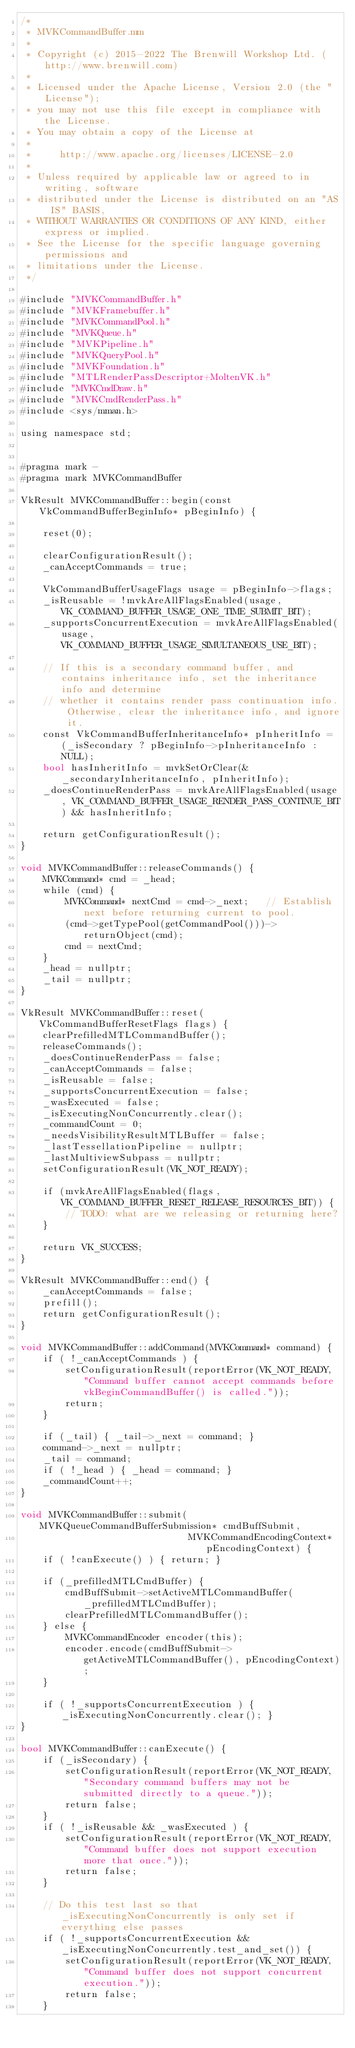<code> <loc_0><loc_0><loc_500><loc_500><_ObjectiveC_>/*
 * MVKCommandBuffer.mm
 *
 * Copyright (c) 2015-2022 The Brenwill Workshop Ltd. (http://www.brenwill.com)
 *
 * Licensed under the Apache License, Version 2.0 (the "License");
 * you may not use this file except in compliance with the License.
 * You may obtain a copy of the License at
 * 
 *     http://www.apache.org/licenses/LICENSE-2.0
 * 
 * Unless required by applicable law or agreed to in writing, software
 * distributed under the License is distributed on an "AS IS" BASIS,
 * WITHOUT WARRANTIES OR CONDITIONS OF ANY KIND, either express or implied.
 * See the License for the specific language governing permissions and
 * limitations under the License.
 */

#include "MVKCommandBuffer.h"
#include "MVKFramebuffer.h"
#include "MVKCommandPool.h"
#include "MVKQueue.h"
#include "MVKPipeline.h"
#include "MVKQueryPool.h"
#include "MVKFoundation.h"
#include "MTLRenderPassDescriptor+MoltenVK.h"
#include "MVKCmdDraw.h"
#include "MVKCmdRenderPass.h"
#include <sys/mman.h>

using namespace std;


#pragma mark -
#pragma mark MVKCommandBuffer

VkResult MVKCommandBuffer::begin(const VkCommandBufferBeginInfo* pBeginInfo) {

	reset(0);

	clearConfigurationResult();
	_canAcceptCommands = true;

	VkCommandBufferUsageFlags usage = pBeginInfo->flags;
	_isReusable = !mvkAreAllFlagsEnabled(usage, VK_COMMAND_BUFFER_USAGE_ONE_TIME_SUBMIT_BIT);
	_supportsConcurrentExecution = mvkAreAllFlagsEnabled(usage, VK_COMMAND_BUFFER_USAGE_SIMULTANEOUS_USE_BIT);

	// If this is a secondary command buffer, and contains inheritance info, set the inheritance info and determine
	// whether it contains render pass continuation info. Otherwise, clear the inheritance info, and ignore it.
	const VkCommandBufferInheritanceInfo* pInheritInfo = (_isSecondary ? pBeginInfo->pInheritanceInfo : NULL);
	bool hasInheritInfo = mvkSetOrClear(&_secondaryInheritanceInfo, pInheritInfo);
	_doesContinueRenderPass = mvkAreAllFlagsEnabled(usage, VK_COMMAND_BUFFER_USAGE_RENDER_PASS_CONTINUE_BIT) && hasInheritInfo;

	return getConfigurationResult();
}

void MVKCommandBuffer::releaseCommands() {
	MVKCommand* cmd = _head;
	while (cmd) {
		MVKCommand* nextCmd = cmd->_next;	// Establish next before returning current to pool.
		(cmd->getTypePool(getCommandPool()))->returnObject(cmd);
		cmd = nextCmd;
	}
	_head = nullptr;
	_tail = nullptr;
}

VkResult MVKCommandBuffer::reset(VkCommandBufferResetFlags flags) {
	clearPrefilledMTLCommandBuffer();
	releaseCommands();
	_doesContinueRenderPass = false;
	_canAcceptCommands = false;
	_isReusable = false;
	_supportsConcurrentExecution = false;
	_wasExecuted = false;
	_isExecutingNonConcurrently.clear();
	_commandCount = 0;
	_needsVisibilityResultMTLBuffer = false;
	_lastTessellationPipeline = nullptr;
	_lastMultiviewSubpass = nullptr;
	setConfigurationResult(VK_NOT_READY);

	if (mvkAreAllFlagsEnabled(flags, VK_COMMAND_BUFFER_RESET_RELEASE_RESOURCES_BIT)) {
		// TODO: what are we releasing or returning here?
	}

	return VK_SUCCESS;
}

VkResult MVKCommandBuffer::end() {
	_canAcceptCommands = false;
	prefill();
	return getConfigurationResult();
}

void MVKCommandBuffer::addCommand(MVKCommand* command) {
	if ( !_canAcceptCommands ) {
		setConfigurationResult(reportError(VK_NOT_READY, "Command buffer cannot accept commands before vkBeginCommandBuffer() is called."));
		return;
	}

    if (_tail) { _tail->_next = command; }
    command->_next = nullptr;
    _tail = command;
    if ( !_head ) { _head = command; }
    _commandCount++;
}

void MVKCommandBuffer::submit(MVKQueueCommandBufferSubmission* cmdBuffSubmit,
							  MVKCommandEncodingContext* pEncodingContext) {
	if ( !canExecute() ) { return; }

	if (_prefilledMTLCmdBuffer) {
		cmdBuffSubmit->setActiveMTLCommandBuffer(_prefilledMTLCmdBuffer);
		clearPrefilledMTLCommandBuffer();
	} else {
		MVKCommandEncoder encoder(this);
		encoder.encode(cmdBuffSubmit->getActiveMTLCommandBuffer(), pEncodingContext);
	}

	if ( !_supportsConcurrentExecution ) { _isExecutingNonConcurrently.clear(); }
}

bool MVKCommandBuffer::canExecute() {
	if (_isSecondary) {
		setConfigurationResult(reportError(VK_NOT_READY, "Secondary command buffers may not be submitted directly to a queue."));
		return false;
	}
	if ( !_isReusable && _wasExecuted ) {
		setConfigurationResult(reportError(VK_NOT_READY, "Command buffer does not support execution more that once."));
		return false;
	}

	// Do this test last so that _isExecutingNonConcurrently is only set if everything else passes
	if ( !_supportsConcurrentExecution && _isExecutingNonConcurrently.test_and_set()) {
		setConfigurationResult(reportError(VK_NOT_READY, "Command buffer does not support concurrent execution."));
		return false;
	}
</code> 